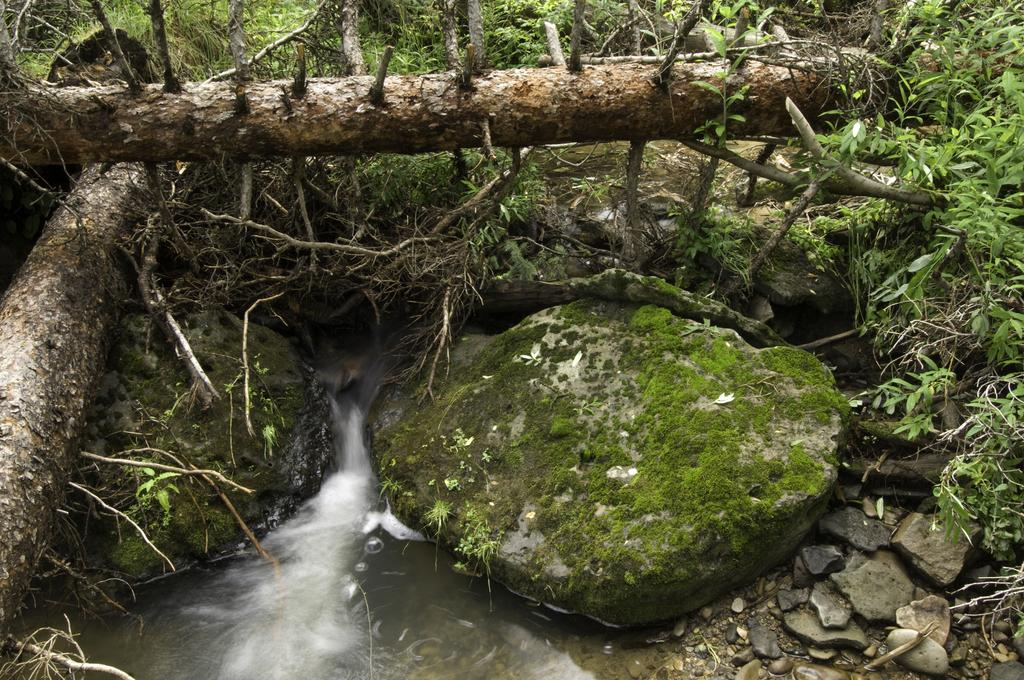What is happening at the bottom of the image? There is water flowing between rocks at the bottom of the image. What type of objects can be seen in the image? Trunks are visible in the image. What else can be found in the image besides rocks and water? Plants are present in the image. What is the terrain like in the image? Rocks are observable in the image. What type of lunch is being served by the maid in the image? There is no maid or lunch present in the image; it features water flowing between rocks, trunks, plants, and rocks. 